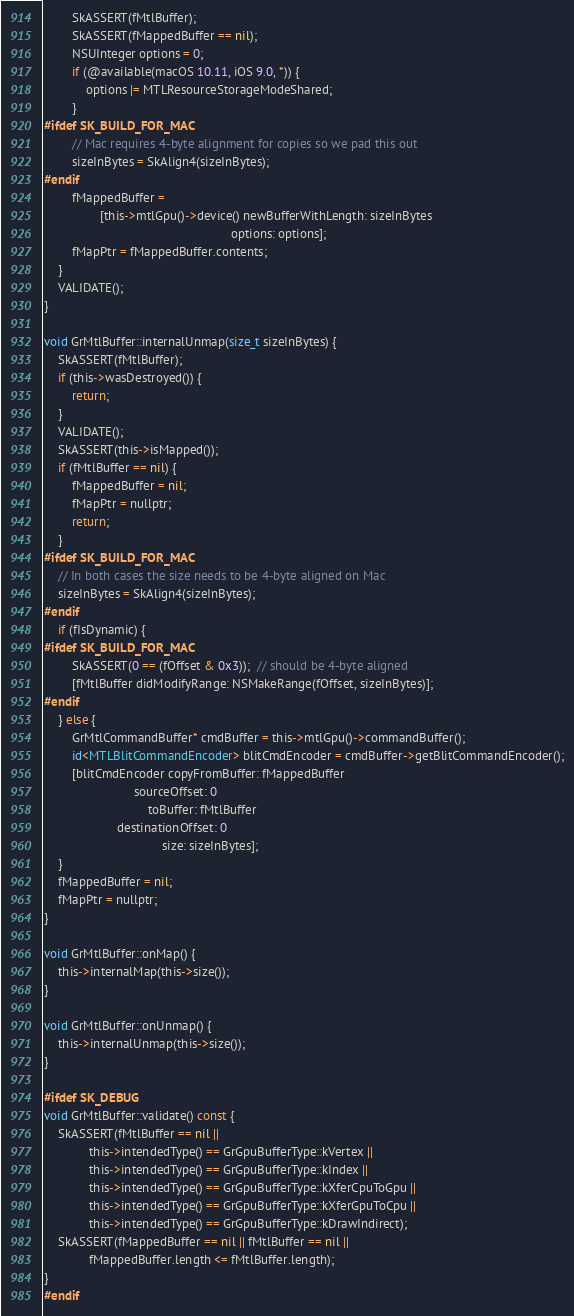<code> <loc_0><loc_0><loc_500><loc_500><_ObjectiveC_>        SkASSERT(fMtlBuffer);
        SkASSERT(fMappedBuffer == nil);
        NSUInteger options = 0;
        if (@available(macOS 10.11, iOS 9.0, *)) {
            options |= MTLResourceStorageModeShared;
        }
#ifdef SK_BUILD_FOR_MAC
        // Mac requires 4-byte alignment for copies so we pad this out
        sizeInBytes = SkAlign4(sizeInBytes);
#endif
        fMappedBuffer =
                [this->mtlGpu()->device() newBufferWithLength: sizeInBytes
                                                      options: options];
        fMapPtr = fMappedBuffer.contents;
    }
    VALIDATE();
}

void GrMtlBuffer::internalUnmap(size_t sizeInBytes) {
    SkASSERT(fMtlBuffer);
    if (this->wasDestroyed()) {
        return;
    }
    VALIDATE();
    SkASSERT(this->isMapped());
    if (fMtlBuffer == nil) {
        fMappedBuffer = nil;
        fMapPtr = nullptr;
        return;
    }
#ifdef SK_BUILD_FOR_MAC
    // In both cases the size needs to be 4-byte aligned on Mac
    sizeInBytes = SkAlign4(sizeInBytes);
#endif
    if (fIsDynamic) {
#ifdef SK_BUILD_FOR_MAC
        SkASSERT(0 == (fOffset & 0x3));  // should be 4-byte aligned
        [fMtlBuffer didModifyRange: NSMakeRange(fOffset, sizeInBytes)];
#endif
    } else {
        GrMtlCommandBuffer* cmdBuffer = this->mtlGpu()->commandBuffer();
        id<MTLBlitCommandEncoder> blitCmdEncoder = cmdBuffer->getBlitCommandEncoder();
        [blitCmdEncoder copyFromBuffer: fMappedBuffer
                          sourceOffset: 0
                              toBuffer: fMtlBuffer
                     destinationOffset: 0
                                  size: sizeInBytes];
    }
    fMappedBuffer = nil;
    fMapPtr = nullptr;
}

void GrMtlBuffer::onMap() {
    this->internalMap(this->size());
}

void GrMtlBuffer::onUnmap() {
    this->internalUnmap(this->size());
}

#ifdef SK_DEBUG
void GrMtlBuffer::validate() const {
    SkASSERT(fMtlBuffer == nil ||
             this->intendedType() == GrGpuBufferType::kVertex ||
             this->intendedType() == GrGpuBufferType::kIndex ||
             this->intendedType() == GrGpuBufferType::kXferCpuToGpu ||
             this->intendedType() == GrGpuBufferType::kXferGpuToCpu ||
             this->intendedType() == GrGpuBufferType::kDrawIndirect);
    SkASSERT(fMappedBuffer == nil || fMtlBuffer == nil ||
             fMappedBuffer.length <= fMtlBuffer.length);
}
#endif
</code> 